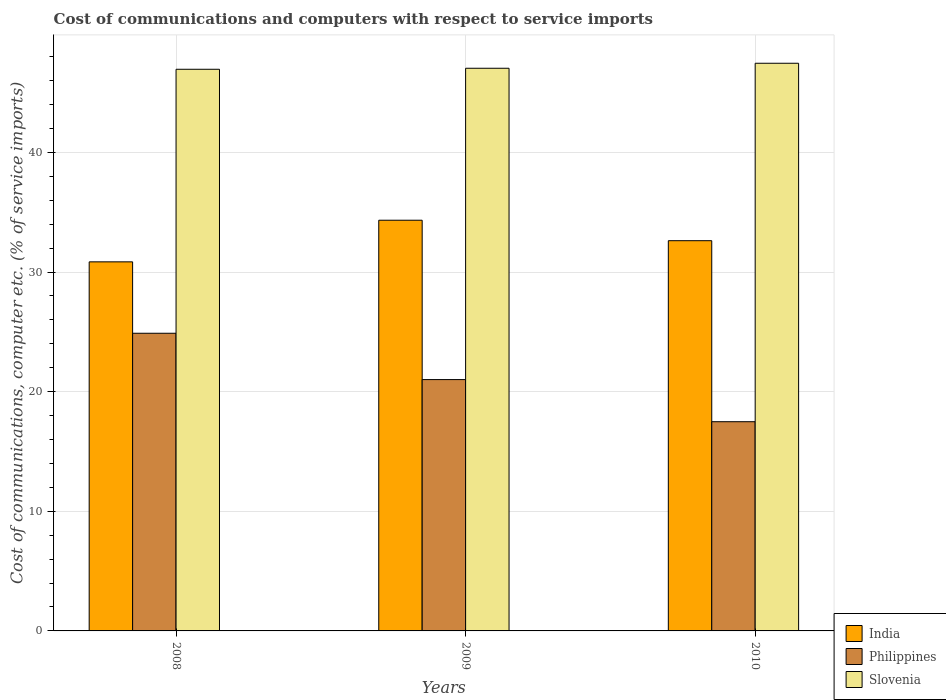How many different coloured bars are there?
Your answer should be compact. 3. Are the number of bars on each tick of the X-axis equal?
Make the answer very short. Yes. How many bars are there on the 1st tick from the left?
Your answer should be very brief. 3. How many bars are there on the 1st tick from the right?
Provide a short and direct response. 3. What is the label of the 2nd group of bars from the left?
Offer a very short reply. 2009. What is the cost of communications and computers in Philippines in 2008?
Your response must be concise. 24.88. Across all years, what is the maximum cost of communications and computers in Philippines?
Give a very brief answer. 24.88. Across all years, what is the minimum cost of communications and computers in Slovenia?
Make the answer very short. 46.95. What is the total cost of communications and computers in India in the graph?
Ensure brevity in your answer.  97.8. What is the difference between the cost of communications and computers in India in 2009 and that in 2010?
Your response must be concise. 1.71. What is the difference between the cost of communications and computers in Philippines in 2008 and the cost of communications and computers in India in 2009?
Offer a terse response. -9.45. What is the average cost of communications and computers in Slovenia per year?
Your answer should be compact. 47.14. In the year 2010, what is the difference between the cost of communications and computers in India and cost of communications and computers in Philippines?
Your response must be concise. 15.13. In how many years, is the cost of communications and computers in India greater than 32 %?
Offer a terse response. 2. What is the ratio of the cost of communications and computers in India in 2008 to that in 2010?
Offer a very short reply. 0.95. Is the cost of communications and computers in India in 2008 less than that in 2009?
Offer a terse response. Yes. Is the difference between the cost of communications and computers in India in 2008 and 2009 greater than the difference between the cost of communications and computers in Philippines in 2008 and 2009?
Give a very brief answer. No. What is the difference between the highest and the second highest cost of communications and computers in India?
Offer a very short reply. 1.71. What is the difference between the highest and the lowest cost of communications and computers in Slovenia?
Your response must be concise. 0.5. In how many years, is the cost of communications and computers in Slovenia greater than the average cost of communications and computers in Slovenia taken over all years?
Keep it short and to the point. 1. What does the 1st bar from the left in 2010 represents?
Make the answer very short. India. How many years are there in the graph?
Offer a very short reply. 3. Does the graph contain any zero values?
Keep it short and to the point. No. Does the graph contain grids?
Your answer should be very brief. Yes. How are the legend labels stacked?
Provide a short and direct response. Vertical. What is the title of the graph?
Your response must be concise. Cost of communications and computers with respect to service imports. What is the label or title of the Y-axis?
Make the answer very short. Cost of communications, computer etc. (% of service imports). What is the Cost of communications, computer etc. (% of service imports) of India in 2008?
Provide a succinct answer. 30.85. What is the Cost of communications, computer etc. (% of service imports) in Philippines in 2008?
Make the answer very short. 24.88. What is the Cost of communications, computer etc. (% of service imports) in Slovenia in 2008?
Keep it short and to the point. 46.95. What is the Cost of communications, computer etc. (% of service imports) of India in 2009?
Your answer should be very brief. 34.33. What is the Cost of communications, computer etc. (% of service imports) in Philippines in 2009?
Offer a terse response. 21.01. What is the Cost of communications, computer etc. (% of service imports) of Slovenia in 2009?
Keep it short and to the point. 47.03. What is the Cost of communications, computer etc. (% of service imports) of India in 2010?
Ensure brevity in your answer.  32.62. What is the Cost of communications, computer etc. (% of service imports) in Philippines in 2010?
Your answer should be compact. 17.49. What is the Cost of communications, computer etc. (% of service imports) in Slovenia in 2010?
Offer a very short reply. 47.45. Across all years, what is the maximum Cost of communications, computer etc. (% of service imports) in India?
Your answer should be compact. 34.33. Across all years, what is the maximum Cost of communications, computer etc. (% of service imports) in Philippines?
Keep it short and to the point. 24.88. Across all years, what is the maximum Cost of communications, computer etc. (% of service imports) in Slovenia?
Provide a short and direct response. 47.45. Across all years, what is the minimum Cost of communications, computer etc. (% of service imports) of India?
Ensure brevity in your answer.  30.85. Across all years, what is the minimum Cost of communications, computer etc. (% of service imports) in Philippines?
Keep it short and to the point. 17.49. Across all years, what is the minimum Cost of communications, computer etc. (% of service imports) of Slovenia?
Your response must be concise. 46.95. What is the total Cost of communications, computer etc. (% of service imports) in India in the graph?
Your response must be concise. 97.8. What is the total Cost of communications, computer etc. (% of service imports) in Philippines in the graph?
Give a very brief answer. 63.38. What is the total Cost of communications, computer etc. (% of service imports) of Slovenia in the graph?
Ensure brevity in your answer.  141.43. What is the difference between the Cost of communications, computer etc. (% of service imports) in India in 2008 and that in 2009?
Ensure brevity in your answer.  -3.48. What is the difference between the Cost of communications, computer etc. (% of service imports) in Philippines in 2008 and that in 2009?
Your answer should be compact. 3.87. What is the difference between the Cost of communications, computer etc. (% of service imports) in Slovenia in 2008 and that in 2009?
Provide a succinct answer. -0.08. What is the difference between the Cost of communications, computer etc. (% of service imports) in India in 2008 and that in 2010?
Your response must be concise. -1.77. What is the difference between the Cost of communications, computer etc. (% of service imports) in Philippines in 2008 and that in 2010?
Your response must be concise. 7.39. What is the difference between the Cost of communications, computer etc. (% of service imports) of Slovenia in 2008 and that in 2010?
Your answer should be compact. -0.5. What is the difference between the Cost of communications, computer etc. (% of service imports) of India in 2009 and that in 2010?
Give a very brief answer. 1.71. What is the difference between the Cost of communications, computer etc. (% of service imports) in Philippines in 2009 and that in 2010?
Provide a succinct answer. 3.52. What is the difference between the Cost of communications, computer etc. (% of service imports) in Slovenia in 2009 and that in 2010?
Keep it short and to the point. -0.42. What is the difference between the Cost of communications, computer etc. (% of service imports) of India in 2008 and the Cost of communications, computer etc. (% of service imports) of Philippines in 2009?
Keep it short and to the point. 9.84. What is the difference between the Cost of communications, computer etc. (% of service imports) of India in 2008 and the Cost of communications, computer etc. (% of service imports) of Slovenia in 2009?
Offer a terse response. -16.18. What is the difference between the Cost of communications, computer etc. (% of service imports) of Philippines in 2008 and the Cost of communications, computer etc. (% of service imports) of Slovenia in 2009?
Offer a terse response. -22.15. What is the difference between the Cost of communications, computer etc. (% of service imports) of India in 2008 and the Cost of communications, computer etc. (% of service imports) of Philippines in 2010?
Your answer should be compact. 13.36. What is the difference between the Cost of communications, computer etc. (% of service imports) in India in 2008 and the Cost of communications, computer etc. (% of service imports) in Slovenia in 2010?
Your answer should be compact. -16.6. What is the difference between the Cost of communications, computer etc. (% of service imports) in Philippines in 2008 and the Cost of communications, computer etc. (% of service imports) in Slovenia in 2010?
Offer a very short reply. -22.57. What is the difference between the Cost of communications, computer etc. (% of service imports) in India in 2009 and the Cost of communications, computer etc. (% of service imports) in Philippines in 2010?
Keep it short and to the point. 16.84. What is the difference between the Cost of communications, computer etc. (% of service imports) of India in 2009 and the Cost of communications, computer etc. (% of service imports) of Slovenia in 2010?
Provide a succinct answer. -13.12. What is the difference between the Cost of communications, computer etc. (% of service imports) of Philippines in 2009 and the Cost of communications, computer etc. (% of service imports) of Slovenia in 2010?
Give a very brief answer. -26.44. What is the average Cost of communications, computer etc. (% of service imports) in India per year?
Keep it short and to the point. 32.6. What is the average Cost of communications, computer etc. (% of service imports) of Philippines per year?
Give a very brief answer. 21.13. What is the average Cost of communications, computer etc. (% of service imports) of Slovenia per year?
Provide a short and direct response. 47.14. In the year 2008, what is the difference between the Cost of communications, computer etc. (% of service imports) in India and Cost of communications, computer etc. (% of service imports) in Philippines?
Make the answer very short. 5.97. In the year 2008, what is the difference between the Cost of communications, computer etc. (% of service imports) of India and Cost of communications, computer etc. (% of service imports) of Slovenia?
Your answer should be compact. -16.1. In the year 2008, what is the difference between the Cost of communications, computer etc. (% of service imports) of Philippines and Cost of communications, computer etc. (% of service imports) of Slovenia?
Provide a succinct answer. -22.07. In the year 2009, what is the difference between the Cost of communications, computer etc. (% of service imports) in India and Cost of communications, computer etc. (% of service imports) in Philippines?
Your answer should be compact. 13.32. In the year 2009, what is the difference between the Cost of communications, computer etc. (% of service imports) of India and Cost of communications, computer etc. (% of service imports) of Slovenia?
Your answer should be very brief. -12.7. In the year 2009, what is the difference between the Cost of communications, computer etc. (% of service imports) of Philippines and Cost of communications, computer etc. (% of service imports) of Slovenia?
Offer a terse response. -26.02. In the year 2010, what is the difference between the Cost of communications, computer etc. (% of service imports) in India and Cost of communications, computer etc. (% of service imports) in Philippines?
Your answer should be very brief. 15.13. In the year 2010, what is the difference between the Cost of communications, computer etc. (% of service imports) in India and Cost of communications, computer etc. (% of service imports) in Slovenia?
Make the answer very short. -14.83. In the year 2010, what is the difference between the Cost of communications, computer etc. (% of service imports) of Philippines and Cost of communications, computer etc. (% of service imports) of Slovenia?
Your answer should be compact. -29.96. What is the ratio of the Cost of communications, computer etc. (% of service imports) of India in 2008 to that in 2009?
Ensure brevity in your answer.  0.9. What is the ratio of the Cost of communications, computer etc. (% of service imports) of Philippines in 2008 to that in 2009?
Offer a very short reply. 1.18. What is the ratio of the Cost of communications, computer etc. (% of service imports) in India in 2008 to that in 2010?
Provide a succinct answer. 0.95. What is the ratio of the Cost of communications, computer etc. (% of service imports) of Philippines in 2008 to that in 2010?
Give a very brief answer. 1.42. What is the ratio of the Cost of communications, computer etc. (% of service imports) of India in 2009 to that in 2010?
Your answer should be very brief. 1.05. What is the ratio of the Cost of communications, computer etc. (% of service imports) of Philippines in 2009 to that in 2010?
Offer a very short reply. 1.2. What is the ratio of the Cost of communications, computer etc. (% of service imports) in Slovenia in 2009 to that in 2010?
Provide a short and direct response. 0.99. What is the difference between the highest and the second highest Cost of communications, computer etc. (% of service imports) in India?
Your response must be concise. 1.71. What is the difference between the highest and the second highest Cost of communications, computer etc. (% of service imports) in Philippines?
Give a very brief answer. 3.87. What is the difference between the highest and the second highest Cost of communications, computer etc. (% of service imports) in Slovenia?
Ensure brevity in your answer.  0.42. What is the difference between the highest and the lowest Cost of communications, computer etc. (% of service imports) of India?
Keep it short and to the point. 3.48. What is the difference between the highest and the lowest Cost of communications, computer etc. (% of service imports) of Philippines?
Offer a very short reply. 7.39. What is the difference between the highest and the lowest Cost of communications, computer etc. (% of service imports) of Slovenia?
Provide a short and direct response. 0.5. 